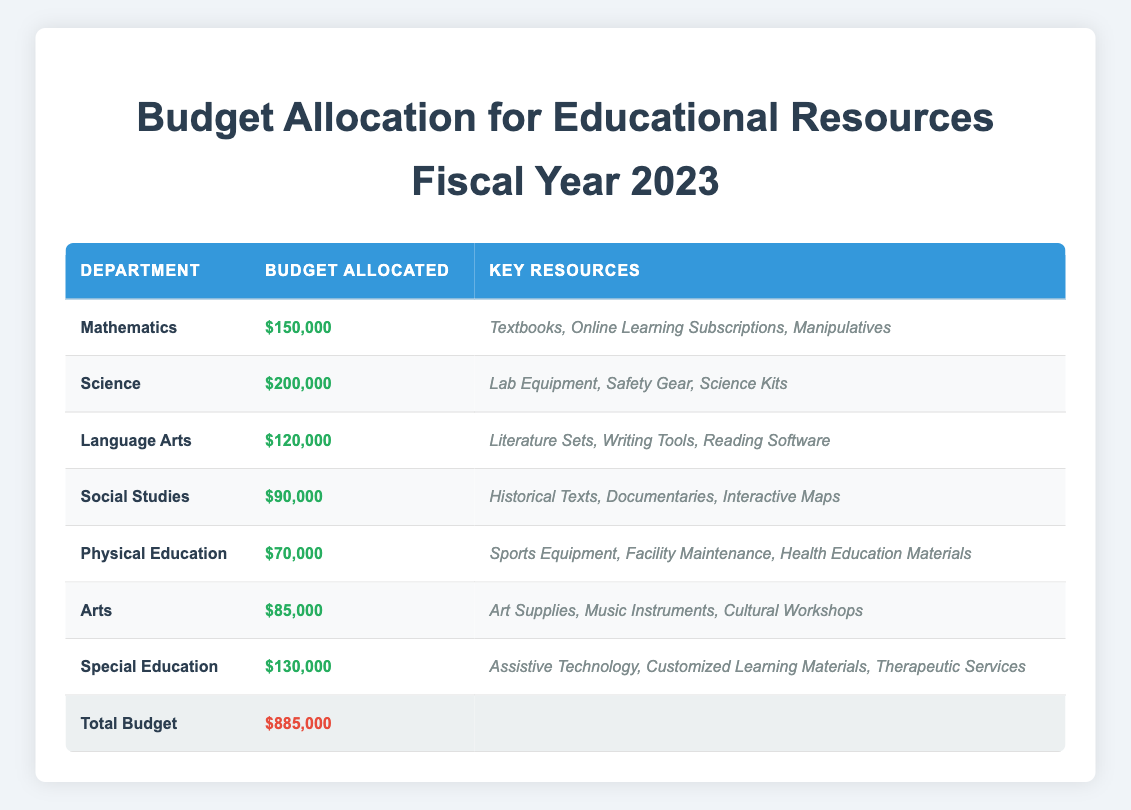What is the budget allocated for the Science department? The table shows that the budget allocated for the Science department is $200,000.
Answer: $200,000 Which department has the smallest budget allocation? By comparing the budget allocations, the Social Studies department has the smallest allocation of $90,000.
Answer: Social Studies What is the total budget for all departments combined? The table states that the total budget is $885,000. This is presented in the totals row of the table.
Answer: $885,000 What is the difference in budget allocation between the Mathematics and Physical Education departments? Mathematics has a budget of $150,000 and Physical Education has a budget of $70,000. The difference is calculated as $150,000 - $70,000 = $80,000.
Answer: $80,000 Do all departments have a budget of at least $80,000? Upon checking the table, the Physical Education department has a budget of $70,000, which is less than $80,000, so the statement is false.
Answer: No What is the average budget allocation for the Language Arts and Arts departments? The budget for Language Arts is $120,000 and for Arts is $85,000. The average is calculated as ($120,000 + $85,000) / 2 = $102,500.
Answer: $102,500 If we combine the budgets of Mathematics, Science, and Special Education, what is the total budget? The budgets are Mathematics: $150,000, Science: $200,000, and Special Education: $130,000. Adding these gives $150,000 + $200,000 + $130,000 = $480,000.
Answer: $480,000 Which department has more than $100,000 allocated to it? Looking through each department's budget, Mathematics, Science, and Special Education have budgets above $100,000. Therefore, there are three departments meeting this criterion.
Answer: Mathematics, Science, Special Education What is the total budget allocated to departments focusing on Physical Education and Arts together? Physical Education has a budget of $70,000 and Arts has a budget of $85,000. Summing these two gives $70,000 + $85,000 = $155,000.
Answer: $155,000 